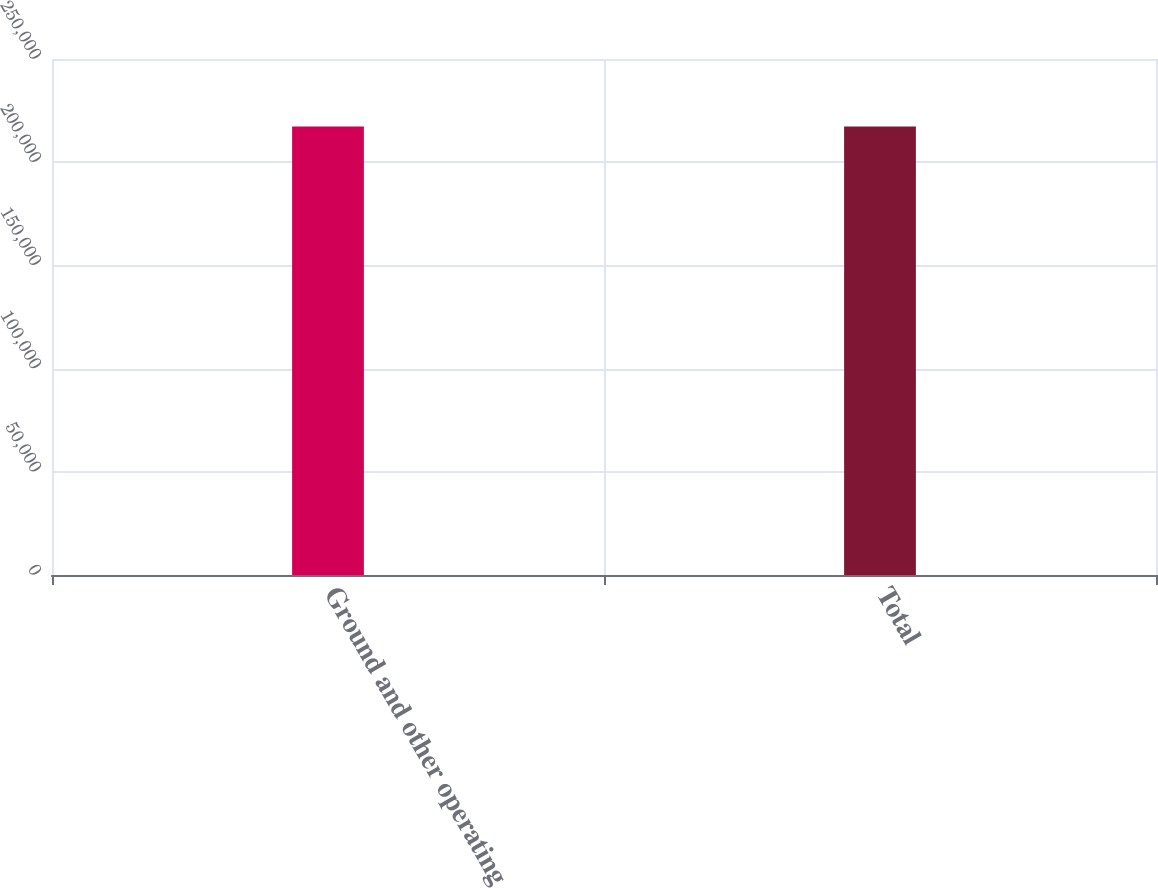<chart> <loc_0><loc_0><loc_500><loc_500><bar_chart><fcel>Ground and other operating<fcel>Total<nl><fcel>217262<fcel>217262<nl></chart> 